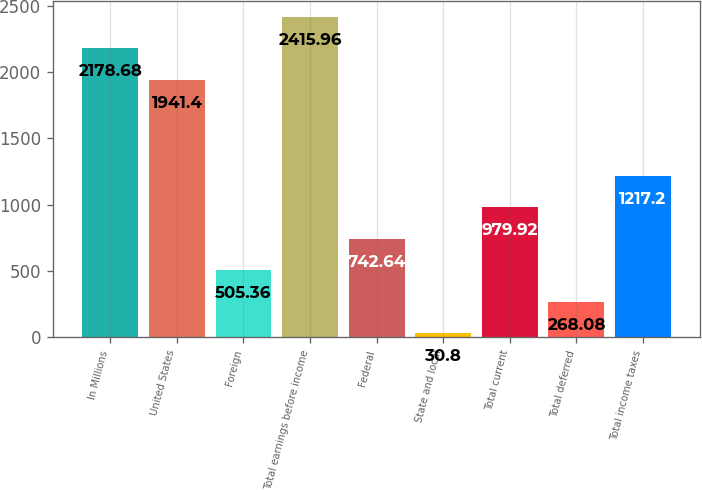Convert chart to OTSL. <chart><loc_0><loc_0><loc_500><loc_500><bar_chart><fcel>In Millions<fcel>United States<fcel>Foreign<fcel>Total earnings before income<fcel>Federal<fcel>State and local<fcel>Total current<fcel>Total deferred<fcel>Total income taxes<nl><fcel>2178.68<fcel>1941.4<fcel>505.36<fcel>2415.96<fcel>742.64<fcel>30.8<fcel>979.92<fcel>268.08<fcel>1217.2<nl></chart> 